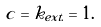<formula> <loc_0><loc_0><loc_500><loc_500>c = k _ { e x t . } = 1 .</formula> 